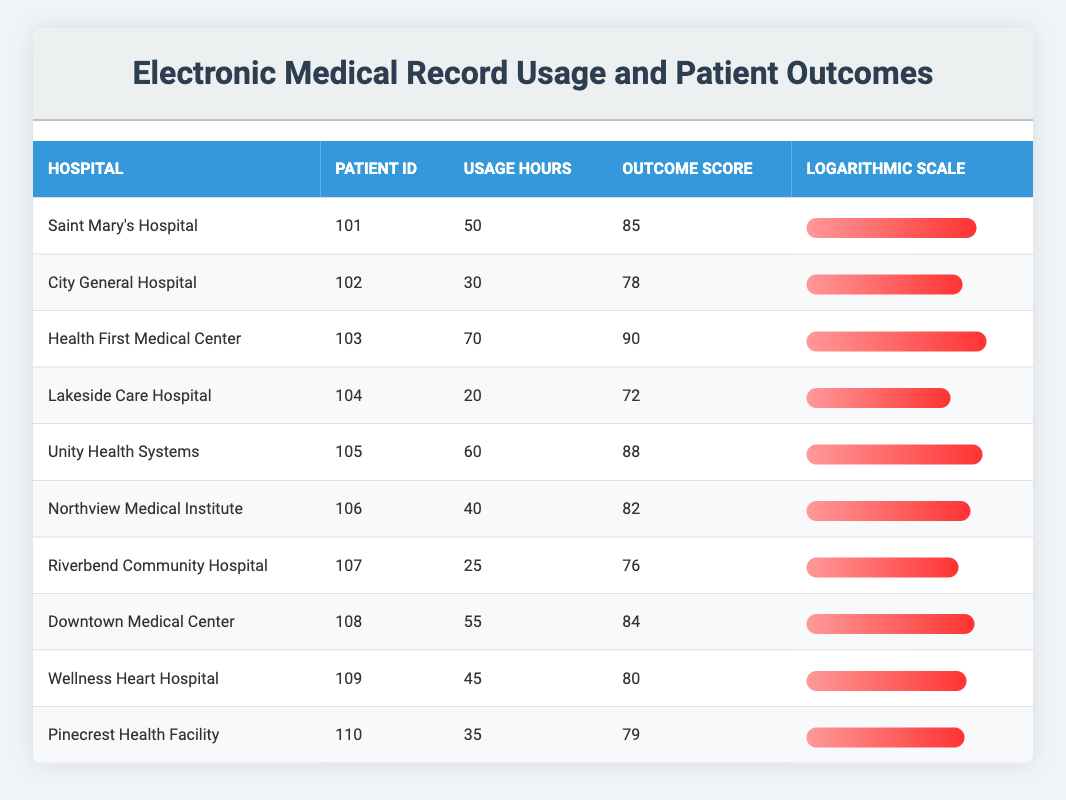What is the highest Outcome Score recorded in the table? By looking at the Outcome Score column, the highest value is 90. This is seen in the entry for Health First Medical Center.
Answer: 90 Which hospital had the least Usage Hours? The Usage Hours column indicates that Lakeside Care Hospital had the least usage at 20 hours.
Answer: Lakeside Care Hospital What is the average Outcome Score for hospitals where Usage Hours is greater than 40? First, identify hospitals with Usage Hours greater than 40, which are Saint Mary's Hospital (85), Health First Medical Center (90), Unity Health Systems (88), Downtown Medical Center (84), Wellness Heart Hospital (80). The sum is 85 + 90 + 88 + 84 + 80 = 427. There are 5 hospitals, so the average Outcome Score is 427 / 5 = 85.4.
Answer: 85.4 Is it true that all hospitals had an Outcome Score greater than 70? By checking the Outcome Score column, all scores are indeed greater than 70, confirming the statement.
Answer: Yes What is the difference between the highest and lowest Usage Hours recorded? The highest Usage Hours is 70 (Health First Medical Center) and the lowest is 20 (Lakeside Care Hospital). The difference is 70 - 20 = 50.
Answer: 50 Which hospital has a Usage Hours and Outcome Score combination closest to 80 and 80? The table indicates that Downtown Medical Center has Usage Hours of 55 and an Outcome Score of 84, which is closest to 80 for both values.
Answer: Downtown Medical Center How many hospitals had an Outcome Score of 80 or higher? By checking the Outcome Score column, the hospitals with a score of 80 or higher are Saint Mary's Hospital, Health First Medical Center, Unity Health Systems, Downtown Medical Center, and Wellness Heart Hospital, totaling 5 hospitals.
Answer: 5 What percentage of hospitals had Usage Hours below 40? The hospitals with Usage Hours below 40 are Lakeside Care Hospital (20), Riverbend Community Hospital (25), and City General Hospital (30). This accounts for 3 out of 10 hospitals, which is (3/10) * 100 = 30%.
Answer: 30% 